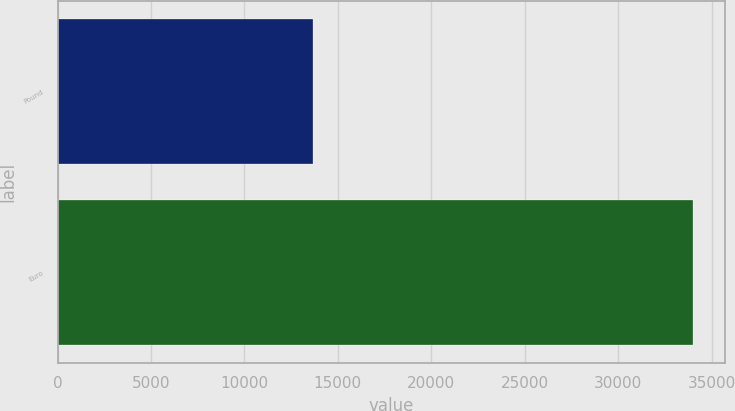Convert chart to OTSL. <chart><loc_0><loc_0><loc_500><loc_500><bar_chart><fcel>Pound<fcel>Euro<nl><fcel>13646<fcel>34000<nl></chart> 